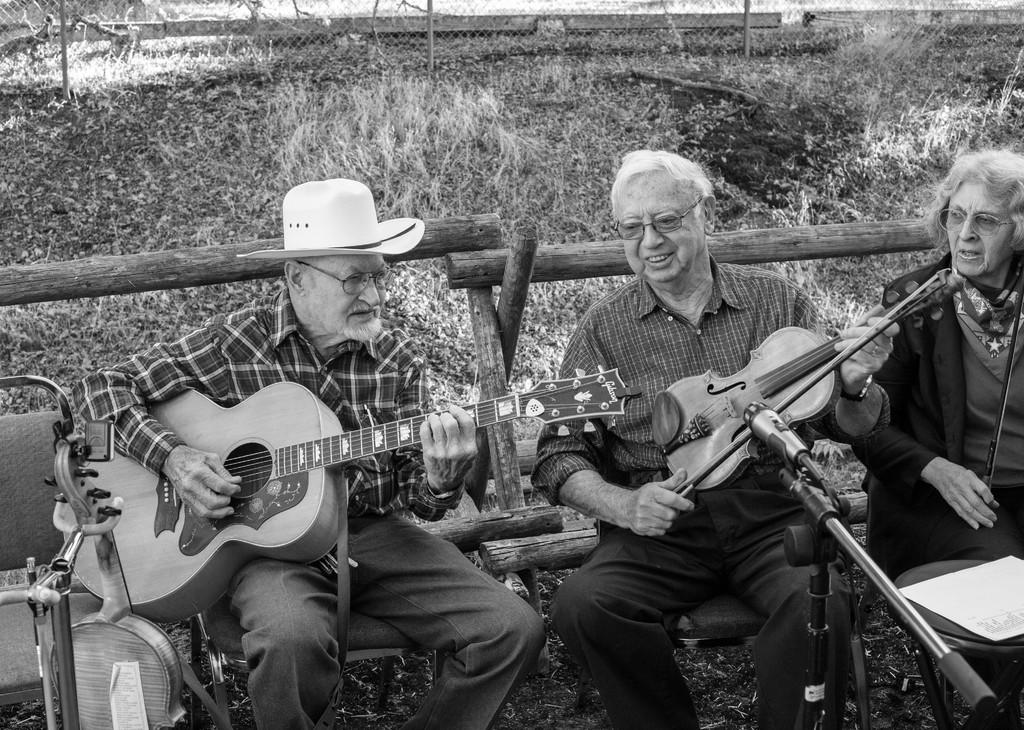How many people are in the image? There are three people in the image. What are the people doing in the image? The people are playing musical instruments. What are the people sitting on in the image? The people are sitting on a wooden object. What type of vegetation can be seen in the image? There is grass visible in the image. What other objects can be seen in the image besides the people and the grass? There are wooden sticks in the image. What month is it in the image? The month is not mentioned or visible in the image, so it cannot be determined. Are there any cabbages visible in the image? There are no cabbages present in the image. 